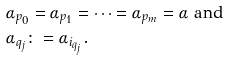<formula> <loc_0><loc_0><loc_500><loc_500>& \alpha _ { p _ { 0 } } = \alpha _ { p _ { 1 } } = \dots = \alpha _ { p _ { m } } = \alpha \text {    and} \\ & \alpha _ { q _ { j } } \colon = \alpha _ { i _ { q _ { j } } } .</formula> 